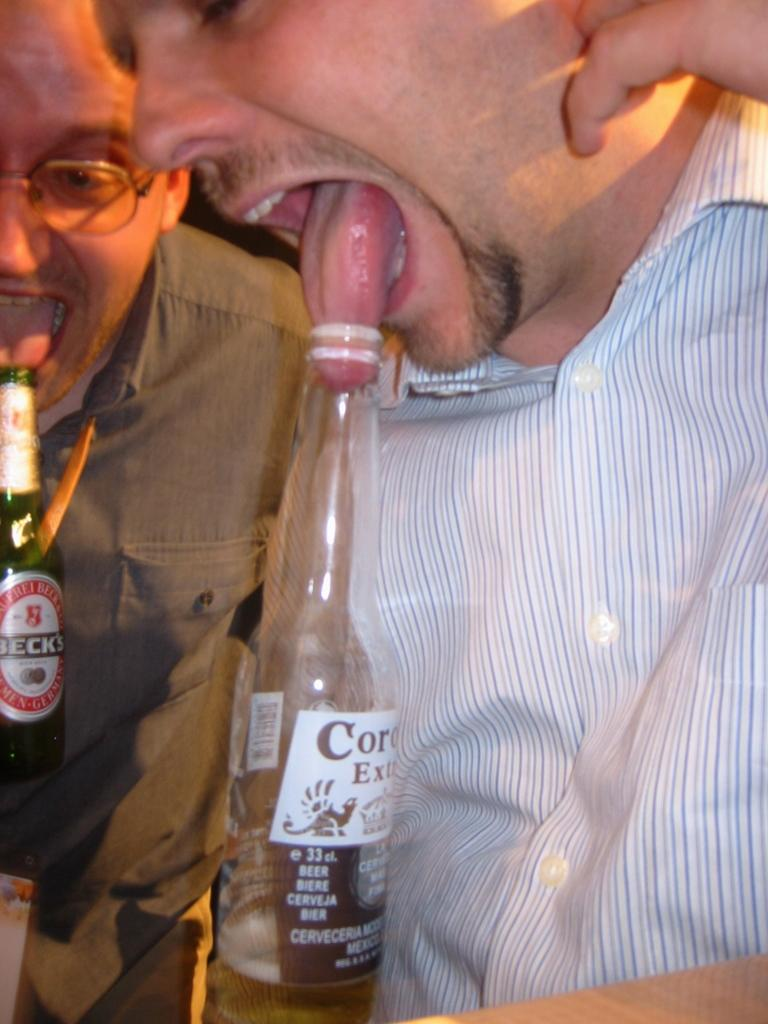What is happening in the image involving the man? In the image, the man is inserting his tongue into a bottle. What is the man wearing in the image? The man is wearing a shirt in the image. Are there any other people in the image? Yes, there is another man in the image. What is the second man doing in the image? The second man is also trying to insert his tongue into a bottle. What type of sack can be seen in the image? There is no sack present in the image. Can you tell me how many cakes are visible in the image? There are no cakes visible in the image; the image features two men attempting to insert their tongues into bottles. 